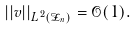<formula> <loc_0><loc_0><loc_500><loc_500>| | v | | _ { L ^ { 2 } ( \mathcal { Z } _ { n } ) } = \mathcal { O } ( 1 ) .</formula> 